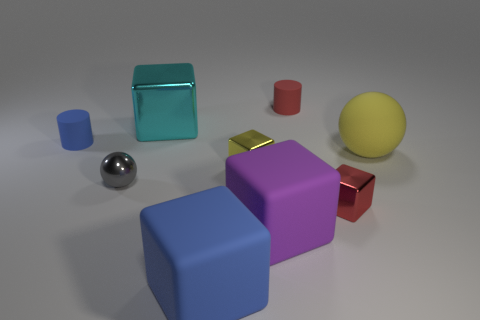Subtract 1 cubes. How many cubes are left? 4 Subtract all blue cylinders. Subtract all red balls. How many cylinders are left? 1 Add 1 red metallic cylinders. How many objects exist? 10 Subtract all cylinders. How many objects are left? 7 Subtract 0 brown spheres. How many objects are left? 9 Subtract all red matte cylinders. Subtract all small gray spheres. How many objects are left? 7 Add 6 red things. How many red things are left? 8 Add 9 tiny blue rubber things. How many tiny blue rubber things exist? 10 